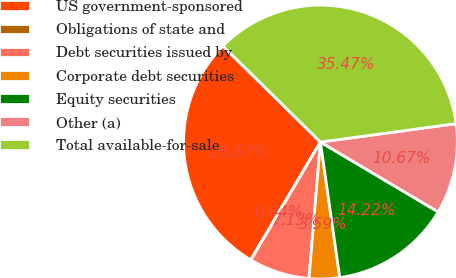Convert chart. <chart><loc_0><loc_0><loc_500><loc_500><pie_chart><fcel>US government-sponsored<fcel>Obligations of state and<fcel>Debt securities issued by<fcel>Corporate debt securities<fcel>Equity securities<fcel>Other (a)<fcel>Total available-for-sale<nl><fcel>28.87%<fcel>0.04%<fcel>7.13%<fcel>3.59%<fcel>14.22%<fcel>10.67%<fcel>35.47%<nl></chart> 